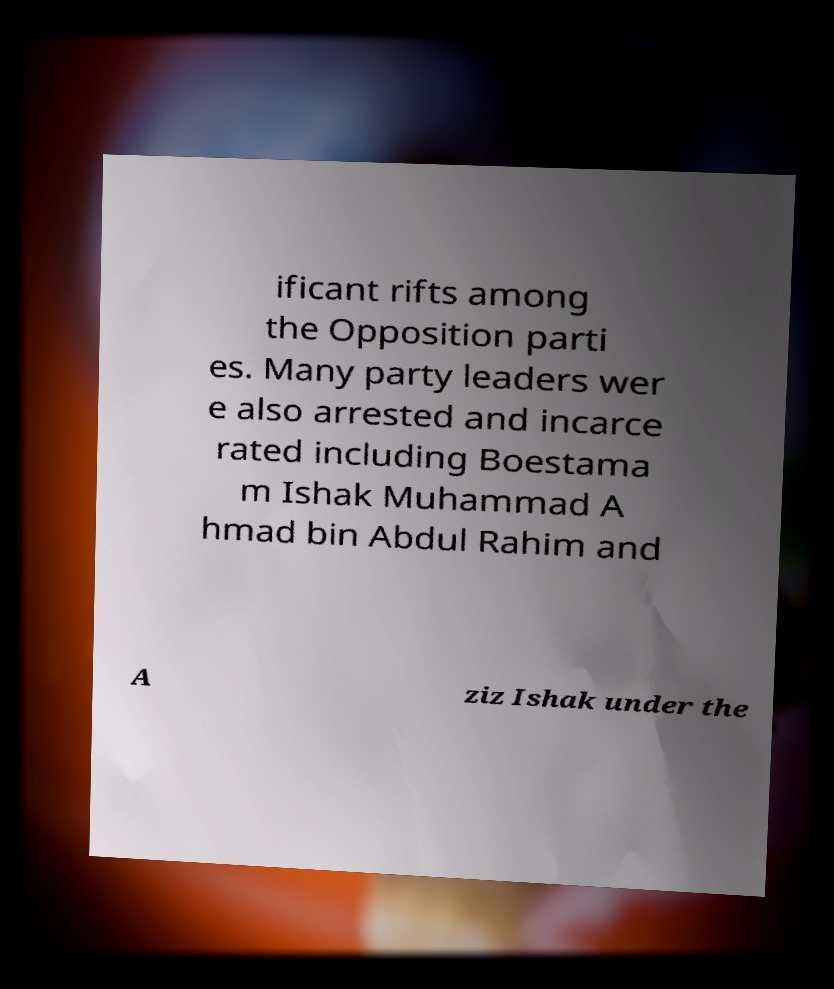Can you read and provide the text displayed in the image?This photo seems to have some interesting text. Can you extract and type it out for me? ificant rifts among the Opposition parti es. Many party leaders wer e also arrested and incarce rated including Boestama m Ishak Muhammad A hmad bin Abdul Rahim and A ziz Ishak under the 